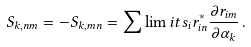Convert formula to latex. <formula><loc_0><loc_0><loc_500><loc_500>S _ { k , n m } = - S _ { k , m n } = \sum \lim i t s _ { i } r ^ { * } _ { i n } \frac { \partial r _ { i m } } { \partial \alpha _ { k } } \, .</formula> 